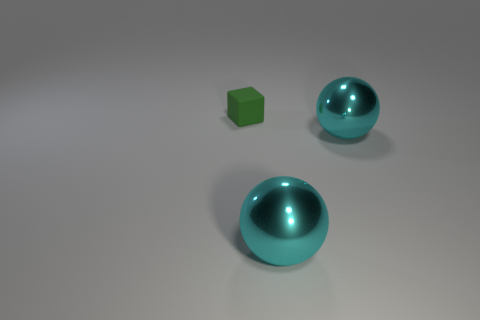Is there another tiny matte thing of the same color as the tiny object?
Provide a succinct answer. No. How many tiny green cubes have the same material as the green object?
Provide a short and direct response. 0. How many objects are either things that are in front of the small green rubber cube or balls?
Offer a very short reply. 2. Are there any other things that have the same shape as the tiny green rubber object?
Give a very brief answer. No. How many large things are either green things or metallic objects?
Make the answer very short. 2. Are there fewer tiny rubber blocks than big cyan spheres?
Your answer should be compact. Yes. Is there anything else that has the same size as the green matte cube?
Make the answer very short. No. Are there more small green rubber balls than green matte things?
Give a very brief answer. No. What number of other objects are the same color as the small object?
Provide a succinct answer. 0. There is a cube; are there any matte objects behind it?
Provide a short and direct response. No. 